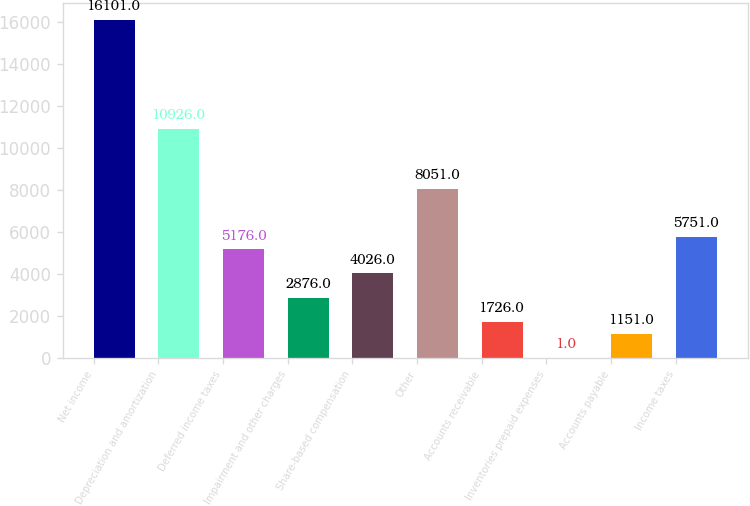<chart> <loc_0><loc_0><loc_500><loc_500><bar_chart><fcel>Net income<fcel>Depreciation and amortization<fcel>Deferred income taxes<fcel>Impairment and other charges<fcel>Share-based compensation<fcel>Other<fcel>Accounts receivable<fcel>Inventories prepaid expenses<fcel>Accounts payable<fcel>Income taxes<nl><fcel>16101<fcel>10926<fcel>5176<fcel>2876<fcel>4026<fcel>8051<fcel>1726<fcel>1<fcel>1151<fcel>5751<nl></chart> 